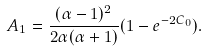<formula> <loc_0><loc_0><loc_500><loc_500>A _ { 1 } = \frac { ( \alpha - 1 ) ^ { 2 } } { 2 \alpha ( \alpha + 1 ) } ( 1 - e ^ { - 2 C _ { 0 } } ) .</formula> 